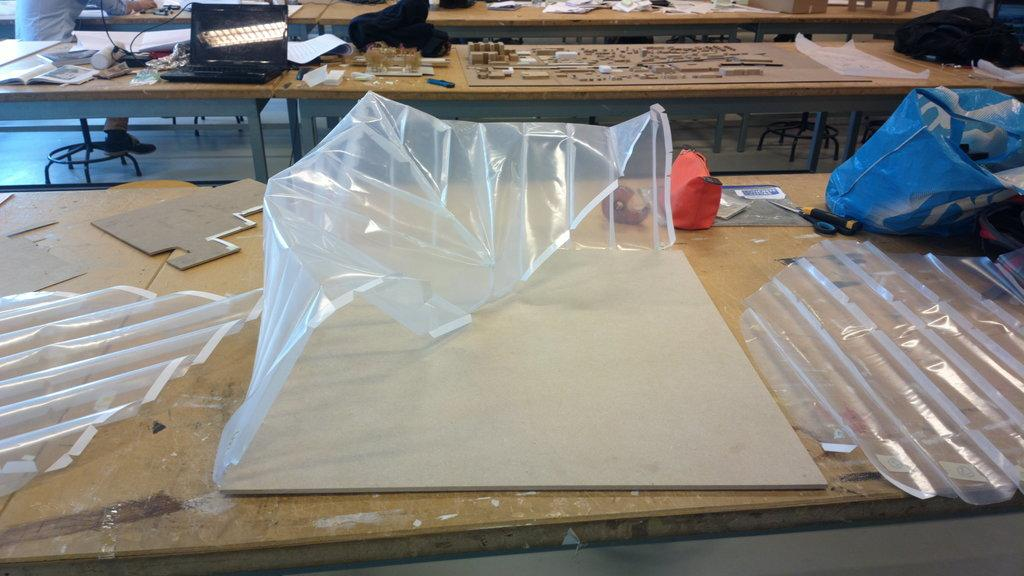What type of furniture is visible in the image? There are tables in the image. What objects are placed on the tables? There are bags and a laptop on the tables. Are there any other items on the tables besides bags and a laptop? Yes, there are other unspecified items on the tables. What can be seen in the front of the image? There are plastic items in the front of the image. Can you see a veil being used for writing on the tables in the image? There is no veil or writing activity present in the image. What type of chalk is being used on the laptop in the image? There is no chalk or writing activity on the laptop in the image. 